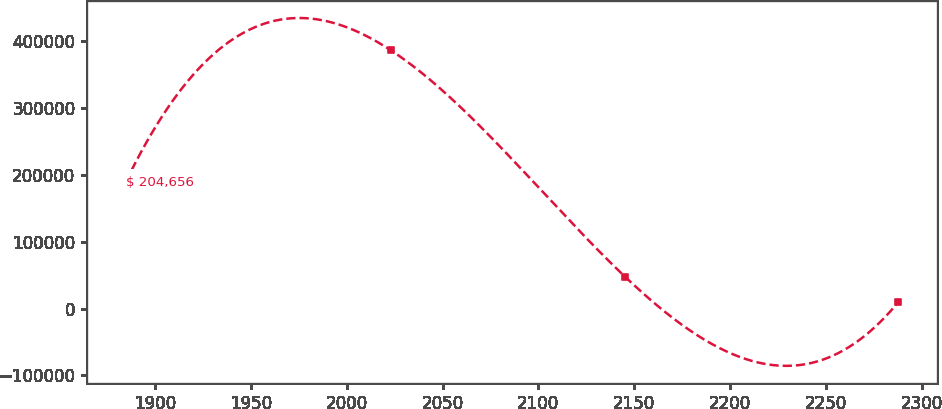<chart> <loc_0><loc_0><loc_500><loc_500><line_chart><ecel><fcel>$ 204,656<nl><fcel>1884.62<fcel>189008<nl><fcel>2023.11<fcel>386359<nl><fcel>2145.47<fcel>47009.7<nl><fcel>2287.75<fcel>9304.13<nl></chart> 